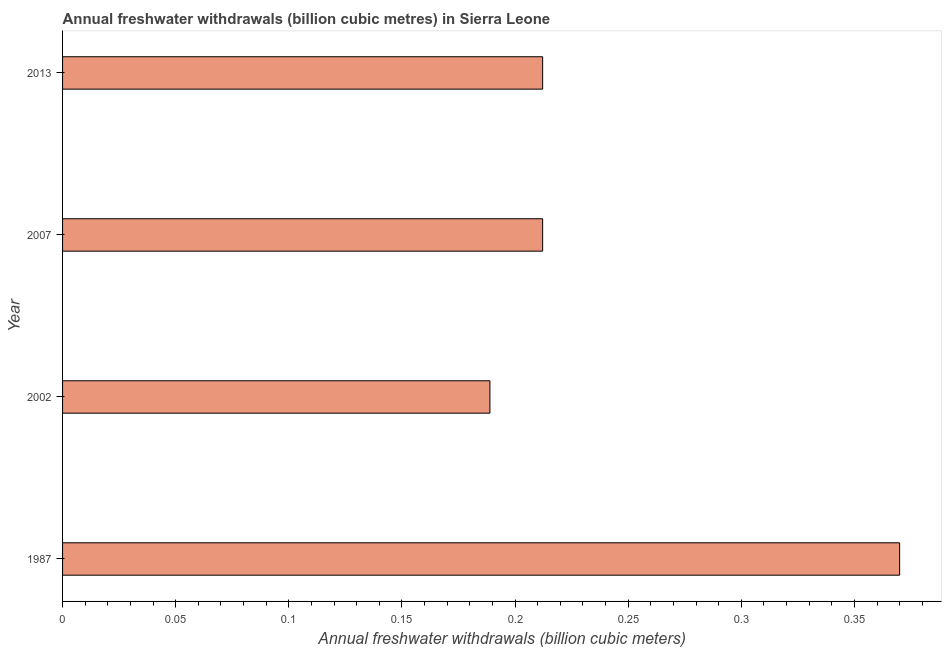Does the graph contain any zero values?
Give a very brief answer. No. Does the graph contain grids?
Keep it short and to the point. No. What is the title of the graph?
Ensure brevity in your answer.  Annual freshwater withdrawals (billion cubic metres) in Sierra Leone. What is the label or title of the X-axis?
Give a very brief answer. Annual freshwater withdrawals (billion cubic meters). What is the label or title of the Y-axis?
Provide a succinct answer. Year. What is the annual freshwater withdrawals in 1987?
Make the answer very short. 0.37. Across all years, what is the maximum annual freshwater withdrawals?
Offer a terse response. 0.37. Across all years, what is the minimum annual freshwater withdrawals?
Ensure brevity in your answer.  0.19. What is the sum of the annual freshwater withdrawals?
Your answer should be very brief. 0.98. What is the difference between the annual freshwater withdrawals in 1987 and 2002?
Offer a terse response. 0.18. What is the average annual freshwater withdrawals per year?
Provide a short and direct response. 0.25. What is the median annual freshwater withdrawals?
Provide a succinct answer. 0.21. In how many years, is the annual freshwater withdrawals greater than 0.18 billion cubic meters?
Offer a terse response. 4. Do a majority of the years between 1987 and 2007 (inclusive) have annual freshwater withdrawals greater than 0.02 billion cubic meters?
Provide a short and direct response. Yes. What is the ratio of the annual freshwater withdrawals in 2002 to that in 2007?
Give a very brief answer. 0.89. What is the difference between the highest and the second highest annual freshwater withdrawals?
Offer a very short reply. 0.16. What is the difference between the highest and the lowest annual freshwater withdrawals?
Your response must be concise. 0.18. In how many years, is the annual freshwater withdrawals greater than the average annual freshwater withdrawals taken over all years?
Your answer should be very brief. 1. How many bars are there?
Provide a succinct answer. 4. Are all the bars in the graph horizontal?
Offer a terse response. Yes. Are the values on the major ticks of X-axis written in scientific E-notation?
Provide a succinct answer. No. What is the Annual freshwater withdrawals (billion cubic meters) of 1987?
Make the answer very short. 0.37. What is the Annual freshwater withdrawals (billion cubic meters) of 2002?
Keep it short and to the point. 0.19. What is the Annual freshwater withdrawals (billion cubic meters) in 2007?
Give a very brief answer. 0.21. What is the Annual freshwater withdrawals (billion cubic meters) of 2013?
Your response must be concise. 0.21. What is the difference between the Annual freshwater withdrawals (billion cubic meters) in 1987 and 2002?
Ensure brevity in your answer.  0.18. What is the difference between the Annual freshwater withdrawals (billion cubic meters) in 1987 and 2007?
Provide a short and direct response. 0.16. What is the difference between the Annual freshwater withdrawals (billion cubic meters) in 1987 and 2013?
Your answer should be very brief. 0.16. What is the difference between the Annual freshwater withdrawals (billion cubic meters) in 2002 and 2007?
Your answer should be very brief. -0.02. What is the difference between the Annual freshwater withdrawals (billion cubic meters) in 2002 and 2013?
Provide a short and direct response. -0.02. What is the ratio of the Annual freshwater withdrawals (billion cubic meters) in 1987 to that in 2002?
Offer a very short reply. 1.96. What is the ratio of the Annual freshwater withdrawals (billion cubic meters) in 1987 to that in 2007?
Provide a short and direct response. 1.74. What is the ratio of the Annual freshwater withdrawals (billion cubic meters) in 1987 to that in 2013?
Ensure brevity in your answer.  1.74. What is the ratio of the Annual freshwater withdrawals (billion cubic meters) in 2002 to that in 2007?
Your response must be concise. 0.89. What is the ratio of the Annual freshwater withdrawals (billion cubic meters) in 2002 to that in 2013?
Make the answer very short. 0.89. What is the ratio of the Annual freshwater withdrawals (billion cubic meters) in 2007 to that in 2013?
Offer a terse response. 1. 